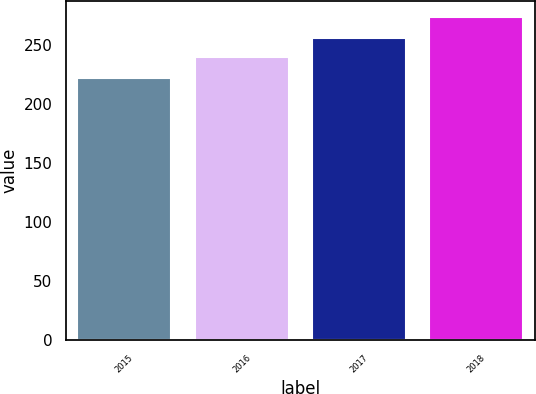<chart> <loc_0><loc_0><loc_500><loc_500><bar_chart><fcel>2015<fcel>2016<fcel>2017<fcel>2018<nl><fcel>222<fcel>240<fcel>256<fcel>274<nl></chart> 